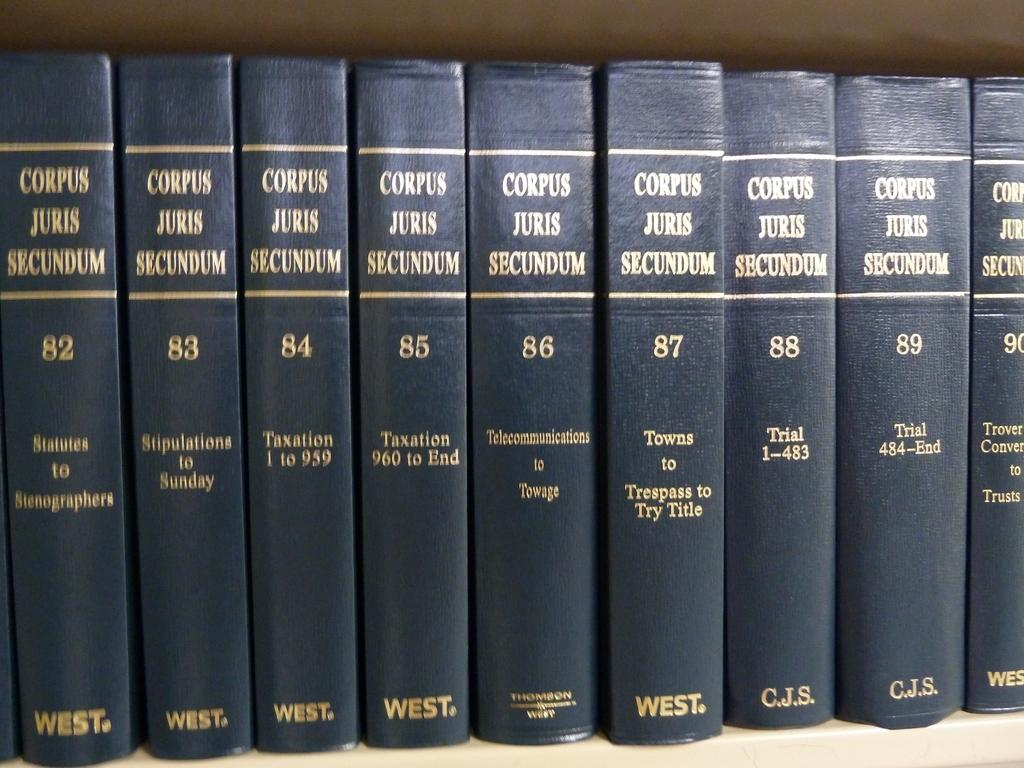<image>
Write a terse but informative summary of the picture. Several books are lined up that are part of the Corpus Juris Secundum series. 